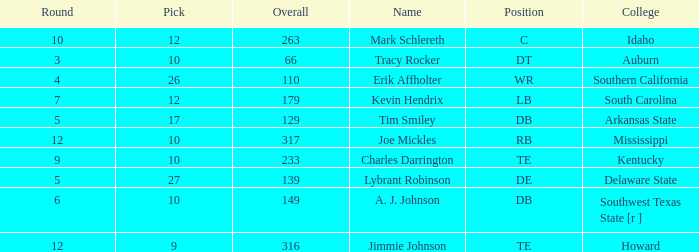Write the full table. {'header': ['Round', 'Pick', 'Overall', 'Name', 'Position', 'College'], 'rows': [['10', '12', '263', 'Mark Schlereth', 'C', 'Idaho'], ['3', '10', '66', 'Tracy Rocker', 'DT', 'Auburn'], ['4', '26', '110', 'Erik Affholter', 'WR', 'Southern California'], ['7', '12', '179', 'Kevin Hendrix', 'LB', 'South Carolina'], ['5', '17', '129', 'Tim Smiley', 'DB', 'Arkansas State'], ['12', '10', '317', 'Joe Mickles', 'RB', 'Mississippi'], ['9', '10', '233', 'Charles Darrington', 'TE', 'Kentucky'], ['5', '27', '139', 'Lybrant Robinson', 'DE', 'Delaware State'], ['6', '10', '149', 'A. J. Johnson', 'DB', 'Southwest Texas State [r ]'], ['12', '9', '316', 'Jimmie Johnson', 'TE', 'Howard']]} What is the sum of Overall, when College is "Arkansas State", and when Pick is less than 17? None. 